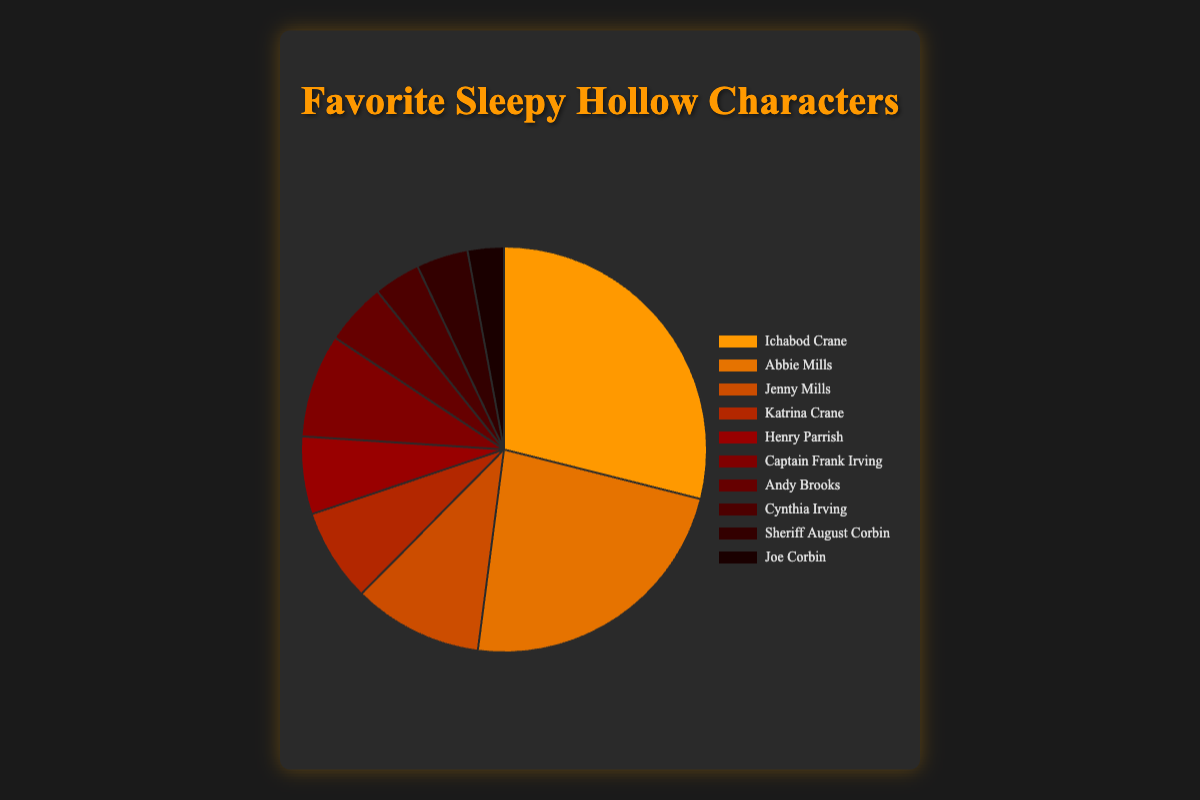Which character received the highest number of votes? The character with the largest section in the pie chart represents the one with the highest number of votes. The largest section belongs to Ichabod Crane.
Answer: Ichabod Crane Which character received the lowest number of votes? The smallest section in the pie chart corresponds to the character with the fewest votes. The smallest section belongs to Joe Corbin.
Answer: Joe Corbin How many more votes did Ichabod Crane receive than Abbie Mills? Ichabod Crane received 350 votes, while Abbie Mills received 280 votes. The difference is 350 - 280.
Answer: 70 Which two characters combined received fewer votes than Ichabod Crane alone? Ichabod Crane received 350 votes. To find two characters whose combined votes are fewer than 350, we look at their vote numbers and add: Jenny Mills (125) and Katrina Crane (90) combined have 125 + 90 = 215, which is less than 350.
Answer: Jenny Mills and Katrina Crane Which character has a pie section colored in the darkest shade of red? The darkest color in the pie chart corresponds to the last entry in the dataset. Joe Corbin's section is the darkest red.
Answer: Joe Corbin What is the sum of votes for the Mills family (Abbie, Jenny)? Abbie Mills received 280 votes, and Jenny Mills received 125 votes. Summing these gives 280 + 125.
Answer: 405 Is the number of votes for Andy Brooks more than Cynthia Irving? Andy Brooks received 60 votes, while Cynthia Irving received 45 votes. Since 60 is more than 45.
Answer: Yes Which character received the median number of votes? To find the median, arrange all votes in ascending order: 35, 45, 50, 60, 75, 90, 100, 125, 280, 350. The median is the average of the 5th and 6th values, which are 75 and 90. (75 + 90) / 2 = 82.5, but since there's no character with exactly 82.5 votes, the median-focused character would be Henry Parrish with 75 votes and Katrina Crane with 90.
Answer: Henry Parrish and Katrina Crane How many votes did Katrina Crane receive relative to Captain Frank Irving (higher, lower, equal)? Katrina Crane received 90 votes while Captain Frank Irving received 100 votes. 90 is lower than 100.
Answer: Lower What percentage of the total votes did Ichabod Crane receive? First find the total votes by summing each character's votes: 350 + 280 + 125 + 90 + 75 + 100 + 60 + 45 + 50 + 35 = 1210. The percentage for Ichabod Crane is (350 / 1210) * 100.
Answer: 28.93% 